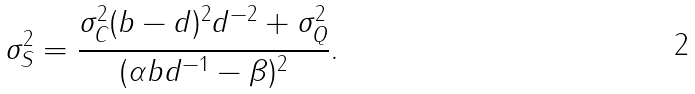<formula> <loc_0><loc_0><loc_500><loc_500>\sigma _ { S } ^ { 2 } = \frac { \sigma _ { C } ^ { 2 } ( b - d ) ^ { 2 } d ^ { - 2 } + \sigma _ { Q } ^ { 2 } } { ( \alpha b d ^ { - 1 } - \beta ) ^ { 2 } } .</formula> 